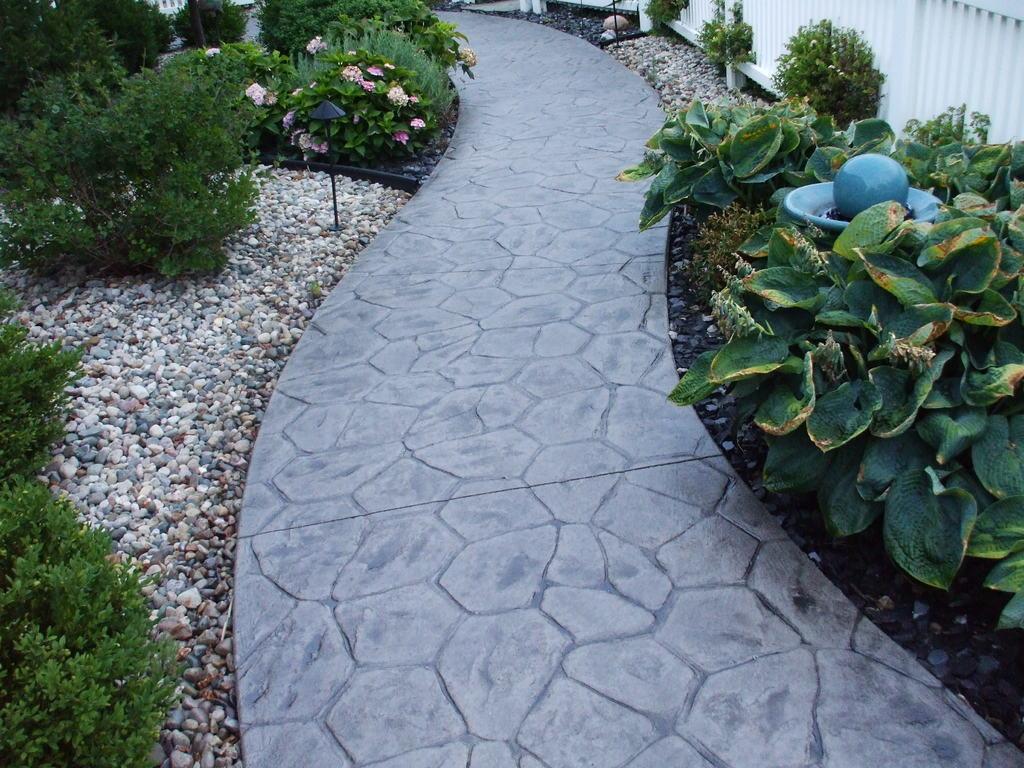How would you summarize this image in a sentence or two? In this image on the right side there are plants and white colour fence. On the left side there are plants and there are stones on the ground and in the background there are flowers. 